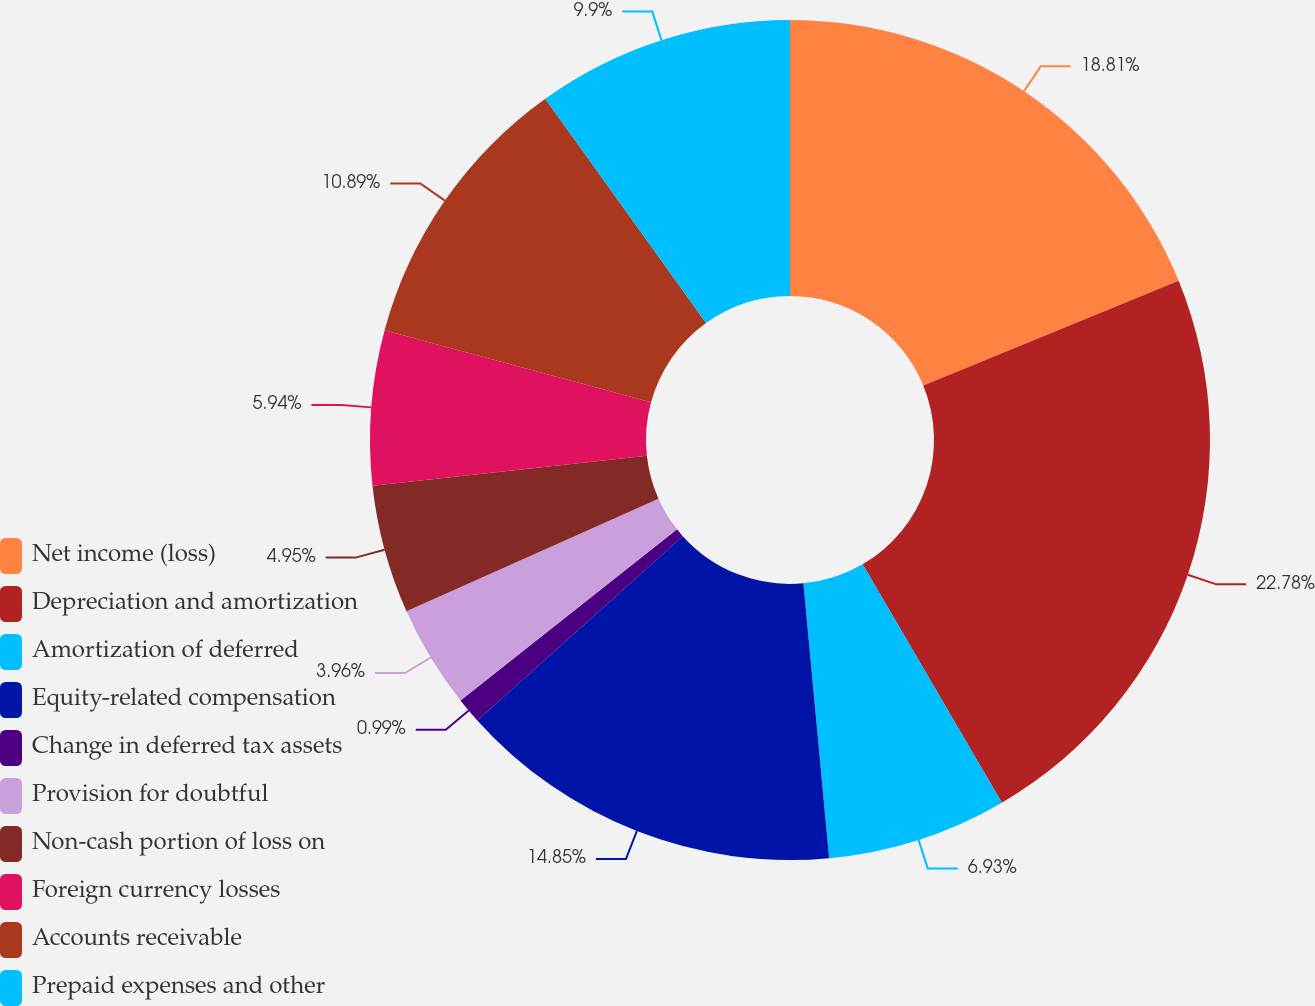Convert chart. <chart><loc_0><loc_0><loc_500><loc_500><pie_chart><fcel>Net income (loss)<fcel>Depreciation and amortization<fcel>Amortization of deferred<fcel>Equity-related compensation<fcel>Change in deferred tax assets<fcel>Provision for doubtful<fcel>Non-cash portion of loss on<fcel>Foreign currency losses<fcel>Accounts receivable<fcel>Prepaid expenses and other<nl><fcel>18.81%<fcel>22.77%<fcel>6.93%<fcel>14.85%<fcel>0.99%<fcel>3.96%<fcel>4.95%<fcel>5.94%<fcel>10.89%<fcel>9.9%<nl></chart> 